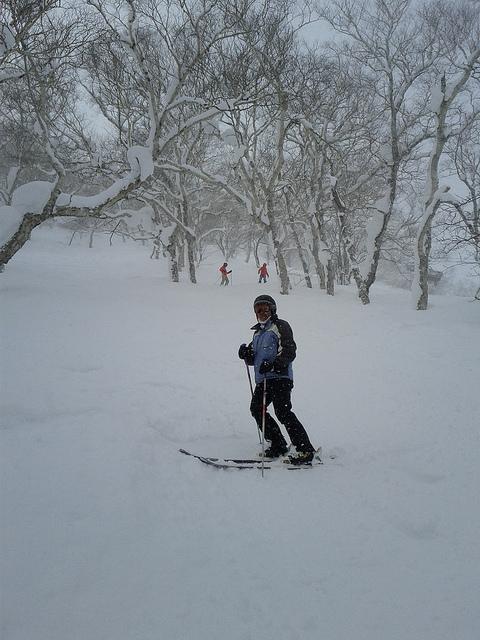What is the season?
Quick response, please. Winter. What kind of trees are in the picture?
Quick response, please. Oak. What activity is this piece of equipment typically used for?
Be succinct. Skiing. Is this person in motion?
Quick response, please. No. What is the person on?
Be succinct. Skis. Does the position illustrate someone moving downhill or stopping?
Be succinct. Stopping. Are those Elm trees?
Write a very short answer. No. What color are the skiers pants?
Short answer required. Black. How many skiers are in the distance?
Short answer required. 2. What color is the ground?
Concise answer only. White. Is it snowing?
Short answer required. Yes. 